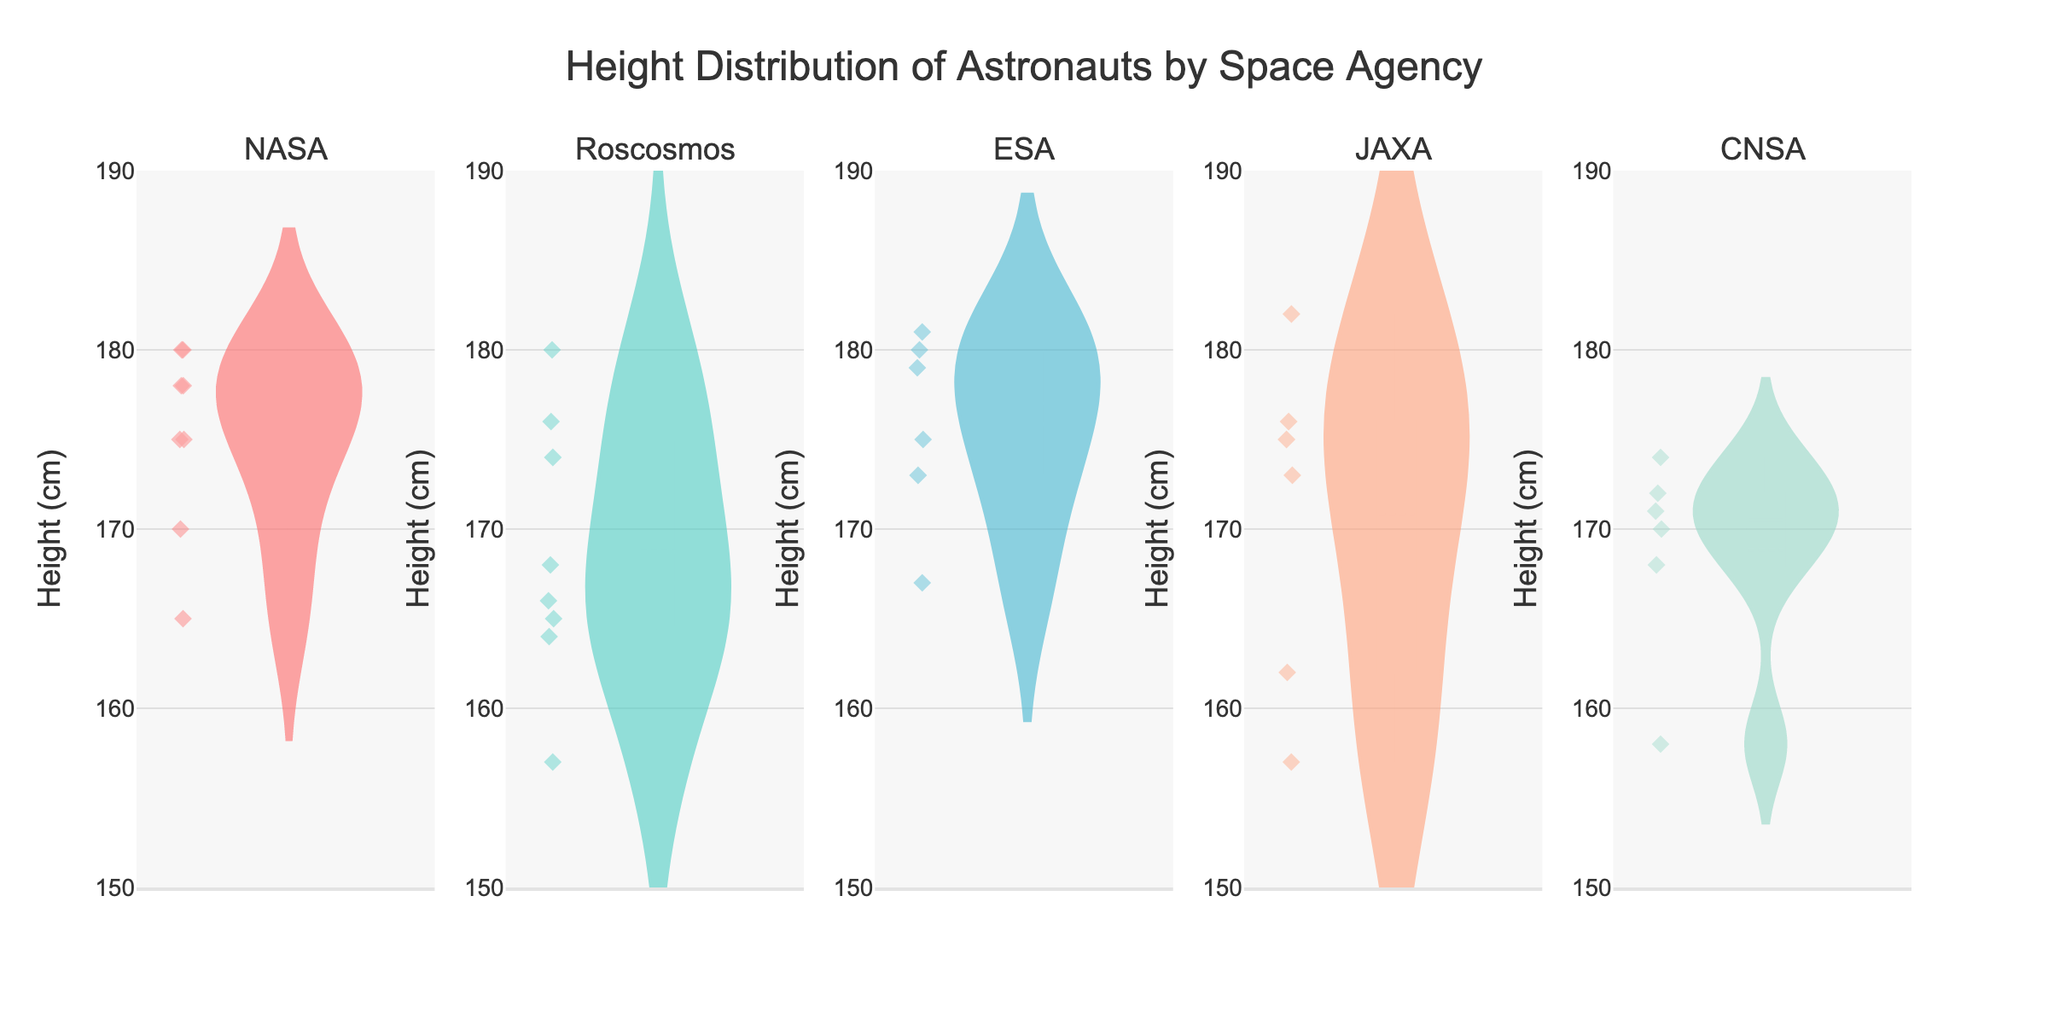What's the title of the figure? The title is usually placed at the top of the figure and summarises the main topic of the visualization. The title here is "Height Distribution of Astronauts by Space Agency".
Answer: Height Distribution of Astronauts by Space Agency How many space agencies are represented in the figure? The figure shows individual violin plots for each space agency. Each subplot title references a different space agency.
Answer: 5 Which space agency has the largest median height? The median height is indicated by the line in the middle of the violin plot. Observing each subplot, ESA's median appears to be the highest.
Answer: ESA Which agency has the most varied height distribution? The varied height distribution is shown by the spread of the violin plot. Roscosmos shows the widest spread among all the agencies.
Answer: Roscosmos Which space agency has the shortest height among its astronauts? Looking at the lower end of each violin plot, Roscosmos seems to have the shortest height as Yuri Gagarin's height is marked at 157 cm.
Answer: Roscosmos Do all space agencies have at least one astronaut with a height of 180 cm or more? Checking the upper end of the violin plots indicates that all agencies except JAXA have at least one astronaut with a height of 180 cm or taller. JAXA's maximum seems to be slightly below 180 cm.
Answer: No Which agency has the tallest astronaut and what is their height? Observing the upper bound of each violin plot, JAXA has Norishige Kanai at 182 cm.
Answer: JAXA, 182 cm Compare the median heights of NASA and CNSA. Which is greater? The median height is depicted by the central line in the violin plots. Comparing these, NASA's median height appears to be slightly greater than CNSA's.
Answer: NASA What's the range of heights for ESA astronauts? The range is the difference between the tallest and shortest heights within an agency. ESA spans from Samantha Cristoforetti's 167 cm to Alexander Gerst's 181 cm. The range is 181 - 167 = 14 cm.
Answer: 14 cm 